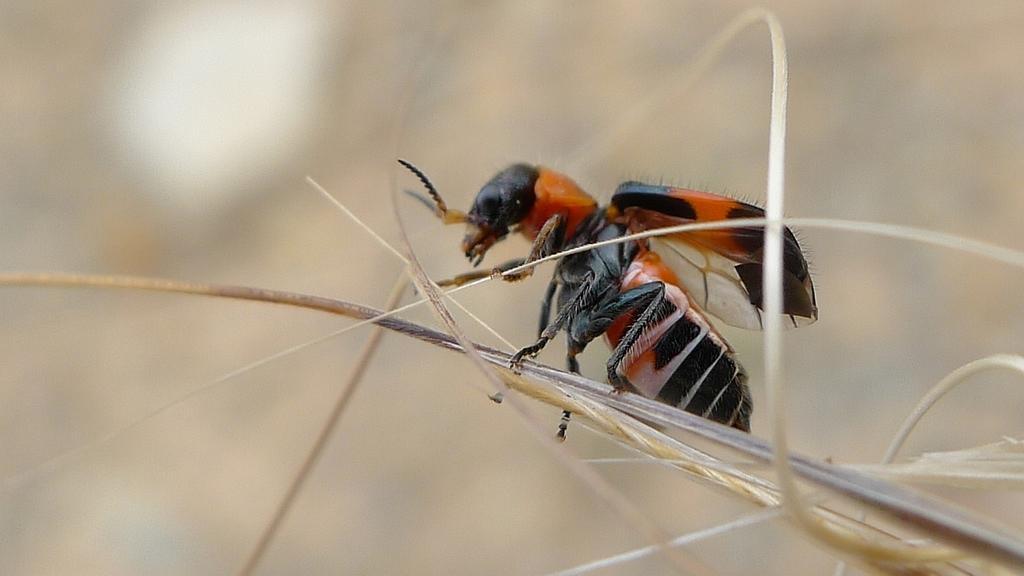Describe this image in one or two sentences. In this picture I can see an insect on the stem, and there is blur background. 